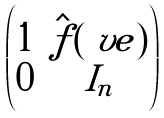Convert formula to latex. <formula><loc_0><loc_0><loc_500><loc_500>\begin{pmatrix} 1 & \hat { f } ( \ v e ) \\ \tilde { 0 } & I _ { n } \\ \end{pmatrix}</formula> 